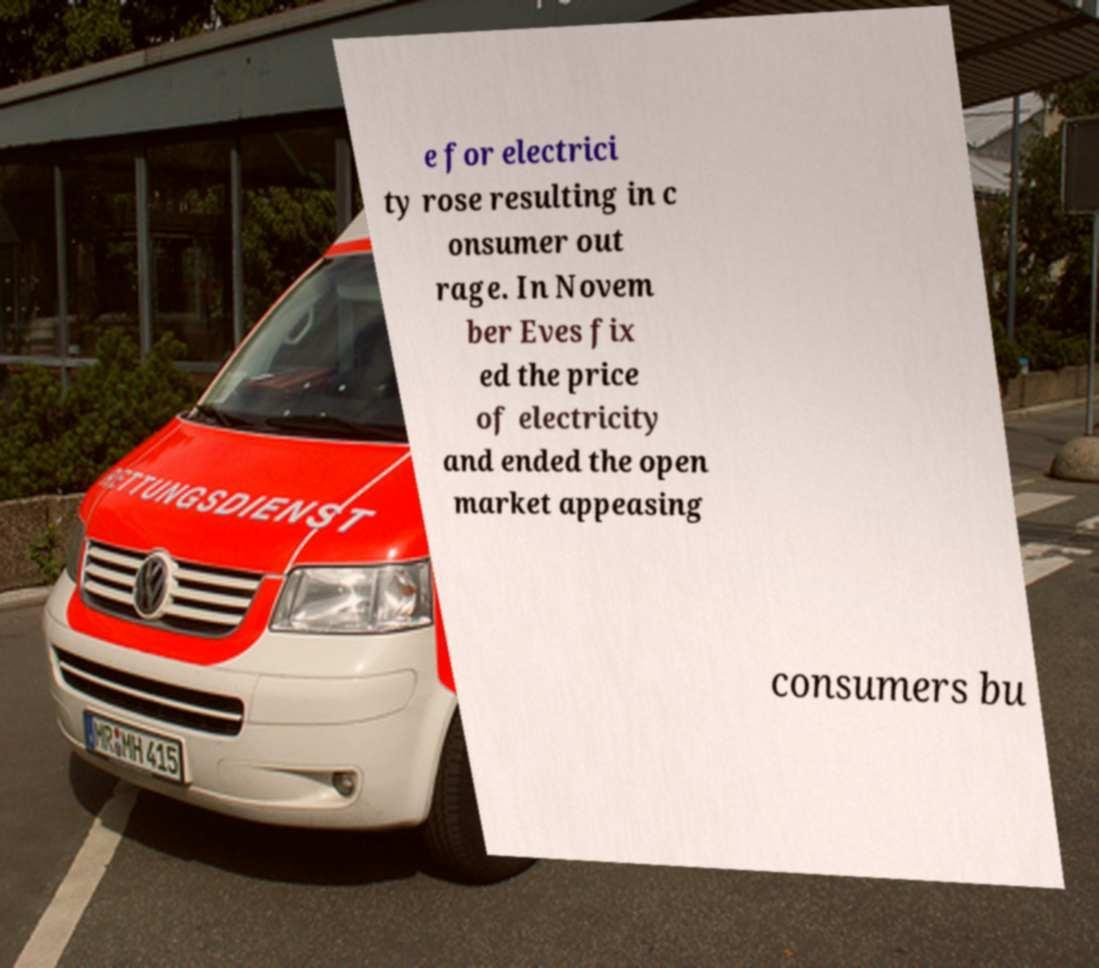Please read and relay the text visible in this image. What does it say? e for electrici ty rose resulting in c onsumer out rage. In Novem ber Eves fix ed the price of electricity and ended the open market appeasing consumers bu 